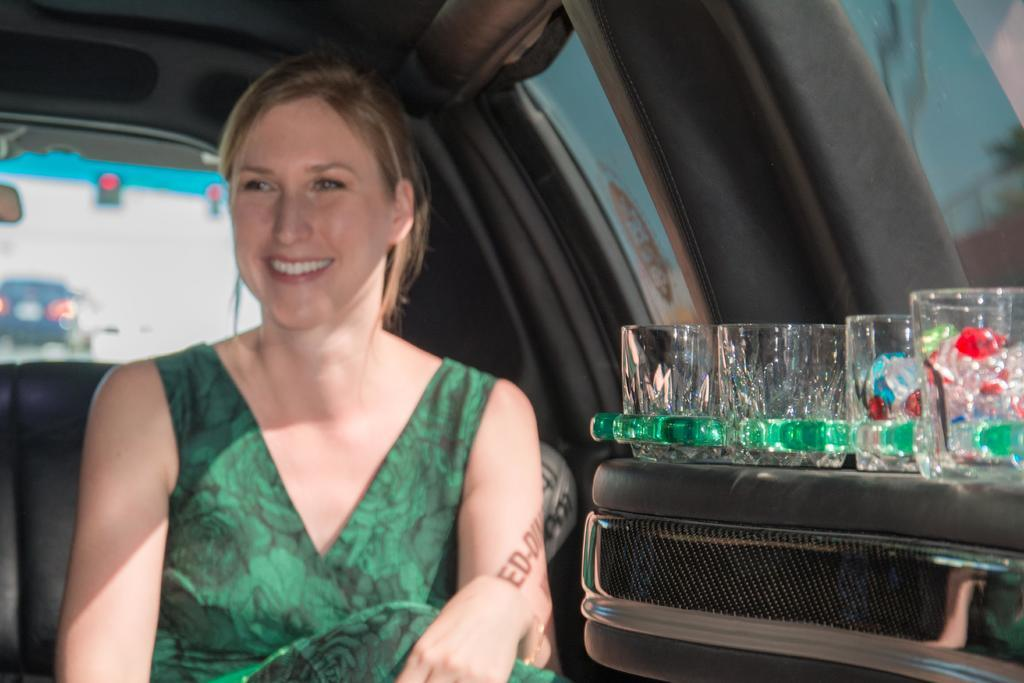Where was the image taken? The image was taken inside a car. Who or what can be seen inside the car? There is a person sitting inside the car. What is on the suitcase inside the car? There are glasses on the suitcase. What can be seen outside the car window? A vehicle is visible outside the car window. What type of poison is being used to grow the lettuce in the image? There is no lettuce or poison present in the image. 